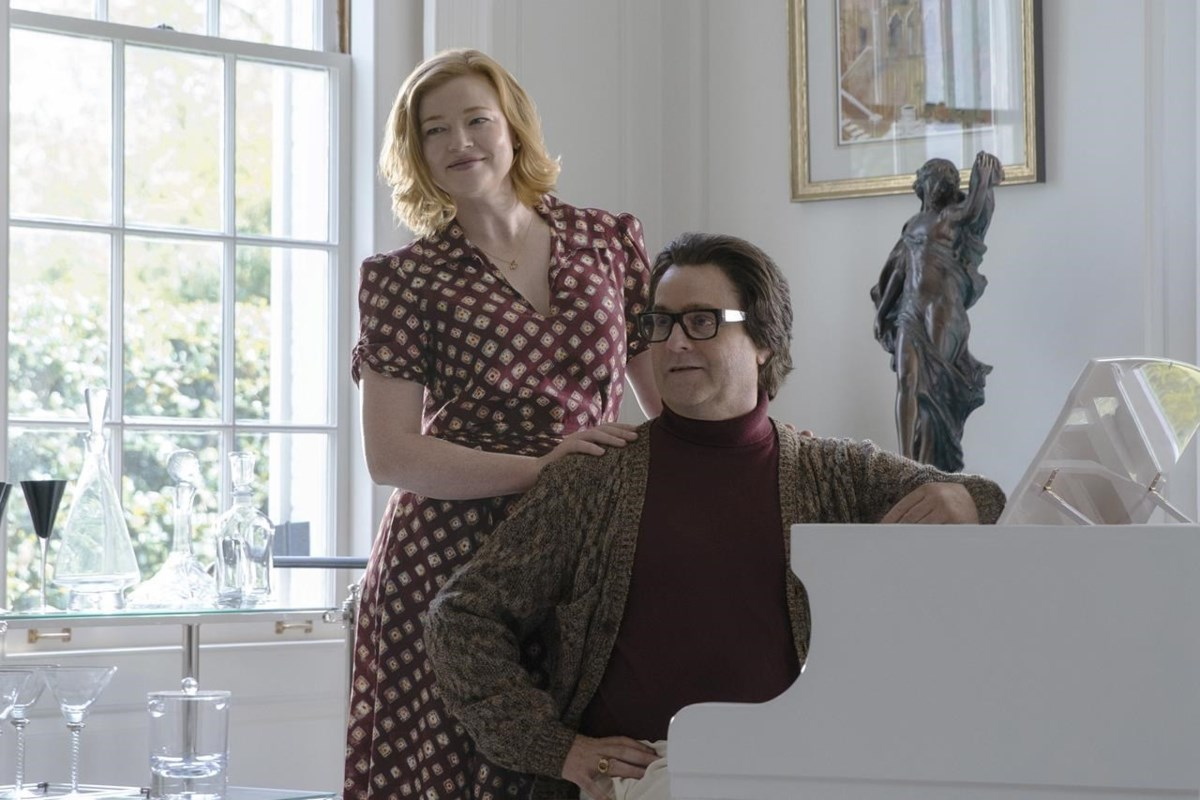What kind of relationship do the characters in the image share? The characters in the image seem to share a close and affectionate relationship. The tender way the person stands with their hand on the piano player's shoulder indicates a sense of support and care. Their shared smile suggests a moment of mutual joy and understanding. This might be a depiction of close friends or family members enjoying a leisurely moment together, sharing fond memories or simply relishing each other’s company in a space that resonates with warmth and connection. 